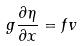<formula> <loc_0><loc_0><loc_500><loc_500>g \frac { \partial \eta } { \partial x } = f v</formula> 